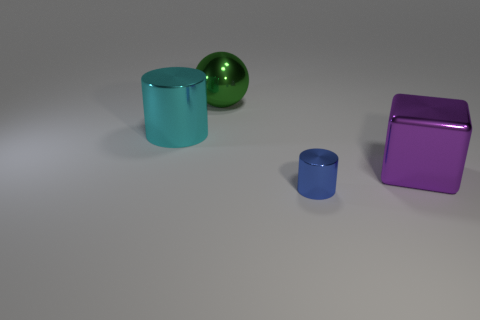Are there any other things that are the same size as the blue object?
Your answer should be very brief. No. Are there any blue metallic cylinders in front of the big purple block?
Offer a terse response. Yes. How many shiny cylinders are in front of the large metal thing right of the blue thing?
Ensure brevity in your answer.  1. There is a green ball that is the same material as the big cylinder; what size is it?
Provide a short and direct response. Large. What size is the purple block?
Make the answer very short. Large. Is the cube made of the same material as the big green object?
Offer a very short reply. Yes. How many spheres are either large cyan objects or big things?
Give a very brief answer. 1. There is a large shiny object behind the shiny cylinder left of the tiny blue metallic cylinder; what color is it?
Give a very brief answer. Green. There is a metallic cylinder that is left of the cylinder right of the large sphere; how many things are behind it?
Ensure brevity in your answer.  1. There is a large cyan object that is behind the small blue cylinder; is it the same shape as the small object in front of the big purple cube?
Offer a very short reply. Yes. 